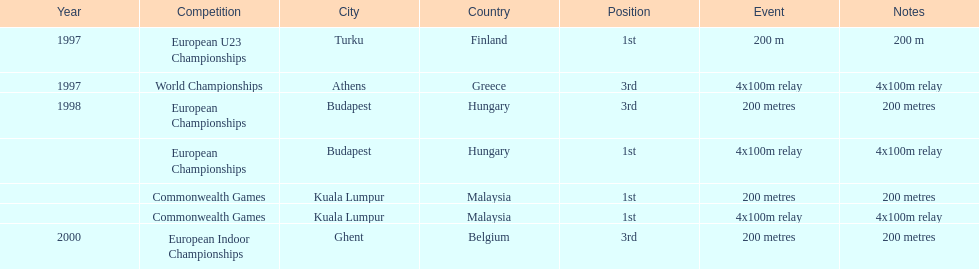In what year between 1997 and 2000 did julian golding, the sprinter representing the united kingdom and england finish first in both the 4 x 100 m relay and the 200 metres race? 1998. 